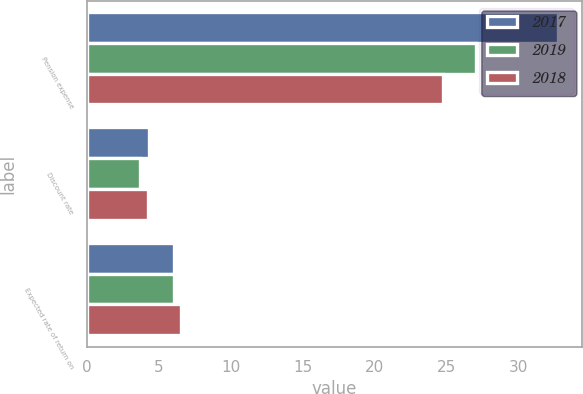Convert chart. <chart><loc_0><loc_0><loc_500><loc_500><stacked_bar_chart><ecel><fcel>Pension expense<fcel>Discount rate<fcel>Expected rate of return on<nl><fcel>2017<fcel>32.8<fcel>4.31<fcel>6.06<nl><fcel>2019<fcel>27.1<fcel>3.66<fcel>6.06<nl><fcel>2018<fcel>24.8<fcel>4.24<fcel>6.55<nl></chart> 